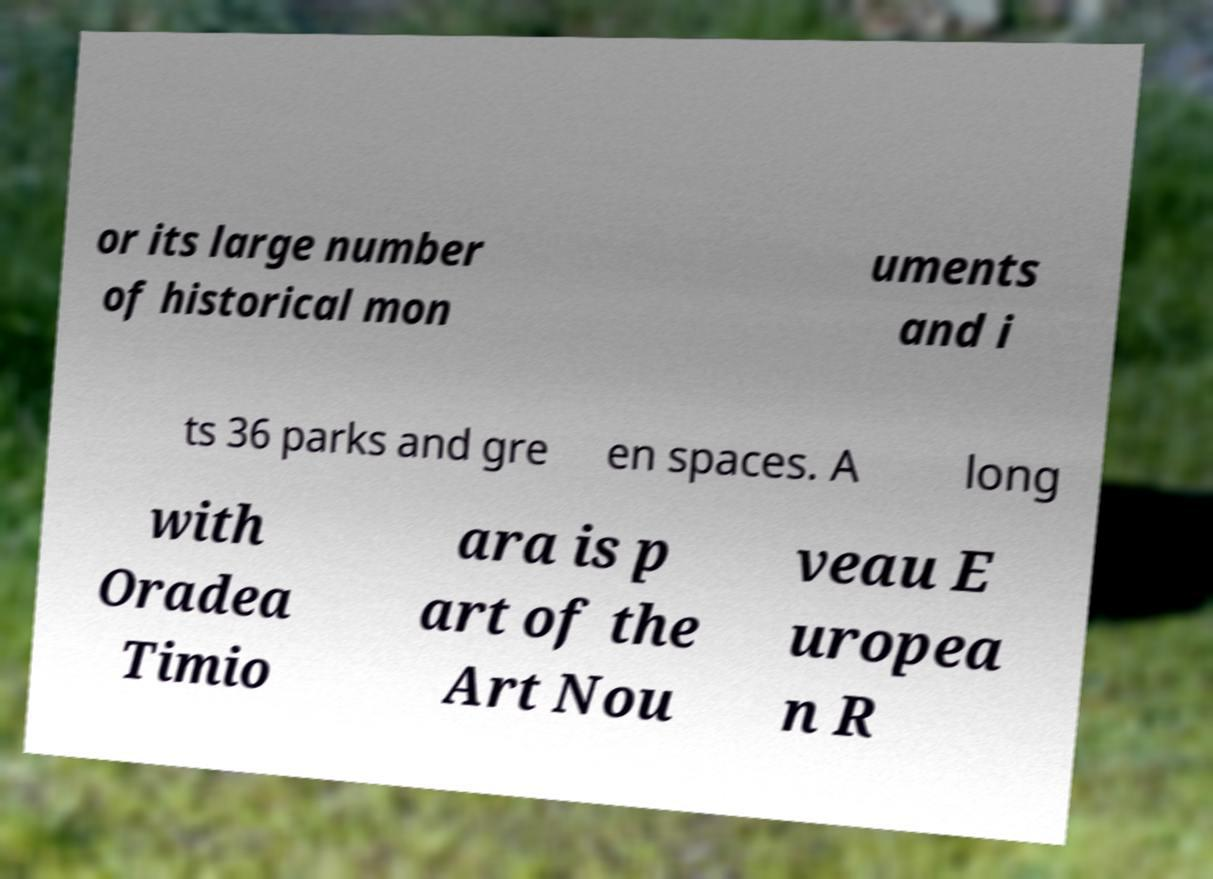There's text embedded in this image that I need extracted. Can you transcribe it verbatim? or its large number of historical mon uments and i ts 36 parks and gre en spaces. A long with Oradea Timio ara is p art of the Art Nou veau E uropea n R 